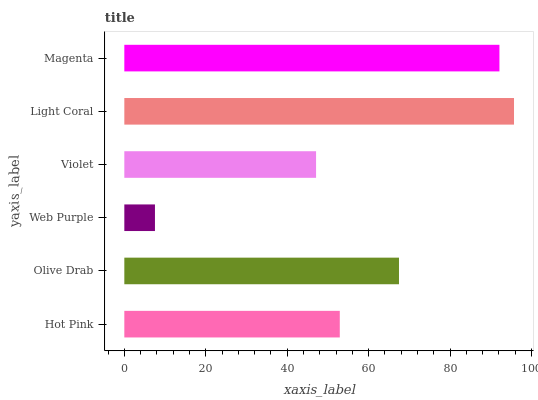Is Web Purple the minimum?
Answer yes or no. Yes. Is Light Coral the maximum?
Answer yes or no. Yes. Is Olive Drab the minimum?
Answer yes or no. No. Is Olive Drab the maximum?
Answer yes or no. No. Is Olive Drab greater than Hot Pink?
Answer yes or no. Yes. Is Hot Pink less than Olive Drab?
Answer yes or no. Yes. Is Hot Pink greater than Olive Drab?
Answer yes or no. No. Is Olive Drab less than Hot Pink?
Answer yes or no. No. Is Olive Drab the high median?
Answer yes or no. Yes. Is Hot Pink the low median?
Answer yes or no. Yes. Is Hot Pink the high median?
Answer yes or no. No. Is Web Purple the low median?
Answer yes or no. No. 